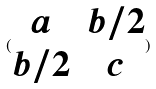Convert formula to latex. <formula><loc_0><loc_0><loc_500><loc_500>( \begin{matrix} a & b / 2 \\ b / 2 & c \end{matrix} )</formula> 